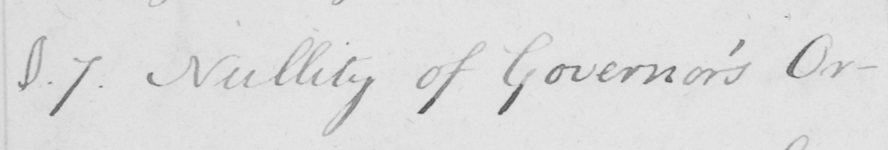Can you read and transcribe this handwriting? §.7 . Nullity of Governor ' s Or- 